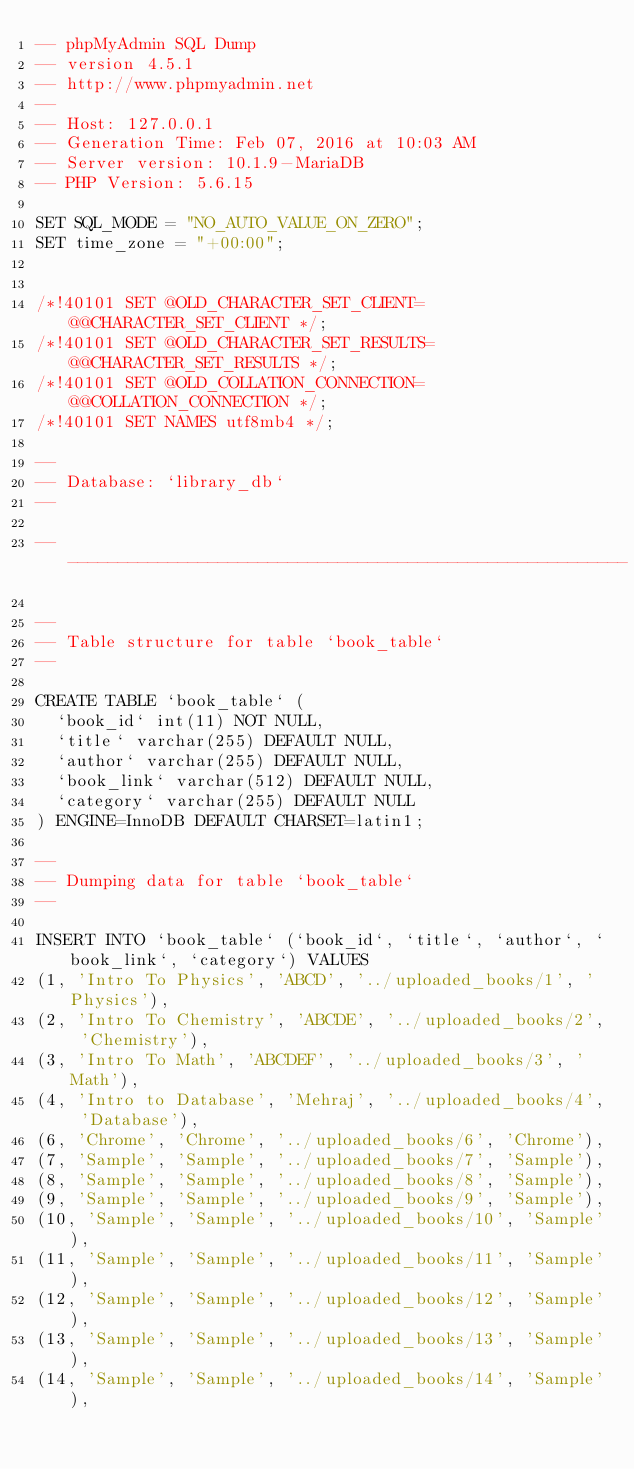<code> <loc_0><loc_0><loc_500><loc_500><_SQL_>-- phpMyAdmin SQL Dump
-- version 4.5.1
-- http://www.phpmyadmin.net
--
-- Host: 127.0.0.1
-- Generation Time: Feb 07, 2016 at 10:03 AM
-- Server version: 10.1.9-MariaDB
-- PHP Version: 5.6.15

SET SQL_MODE = "NO_AUTO_VALUE_ON_ZERO";
SET time_zone = "+00:00";


/*!40101 SET @OLD_CHARACTER_SET_CLIENT=@@CHARACTER_SET_CLIENT */;
/*!40101 SET @OLD_CHARACTER_SET_RESULTS=@@CHARACTER_SET_RESULTS */;
/*!40101 SET @OLD_COLLATION_CONNECTION=@@COLLATION_CONNECTION */;
/*!40101 SET NAMES utf8mb4 */;

--
-- Database: `library_db`
--

-- --------------------------------------------------------

--
-- Table structure for table `book_table`
--

CREATE TABLE `book_table` (
  `book_id` int(11) NOT NULL,
  `title` varchar(255) DEFAULT NULL,
  `author` varchar(255) DEFAULT NULL,
  `book_link` varchar(512) DEFAULT NULL,
  `category` varchar(255) DEFAULT NULL
) ENGINE=InnoDB DEFAULT CHARSET=latin1;

--
-- Dumping data for table `book_table`
--

INSERT INTO `book_table` (`book_id`, `title`, `author`, `book_link`, `category`) VALUES
(1, 'Intro To Physics', 'ABCD', '../uploaded_books/1', 'Physics'),
(2, 'Intro To Chemistry', 'ABCDE', '../uploaded_books/2', 'Chemistry'),
(3, 'Intro To Math', 'ABCDEF', '../uploaded_books/3', 'Math'),
(4, 'Intro to Database', 'Mehraj', '../uploaded_books/4', 'Database'),
(6, 'Chrome', 'Chrome', '../uploaded_books/6', 'Chrome'),
(7, 'Sample', 'Sample', '../uploaded_books/7', 'Sample'),
(8, 'Sample', 'Sample', '../uploaded_books/8', 'Sample'),
(9, 'Sample', 'Sample', '../uploaded_books/9', 'Sample'),
(10, 'Sample', 'Sample', '../uploaded_books/10', 'Sample'),
(11, 'Sample', 'Sample', '../uploaded_books/11', 'Sample'),
(12, 'Sample', 'Sample', '../uploaded_books/12', 'Sample'),
(13, 'Sample', 'Sample', '../uploaded_books/13', 'Sample'),
(14, 'Sample', 'Sample', '../uploaded_books/14', 'Sample'),</code> 